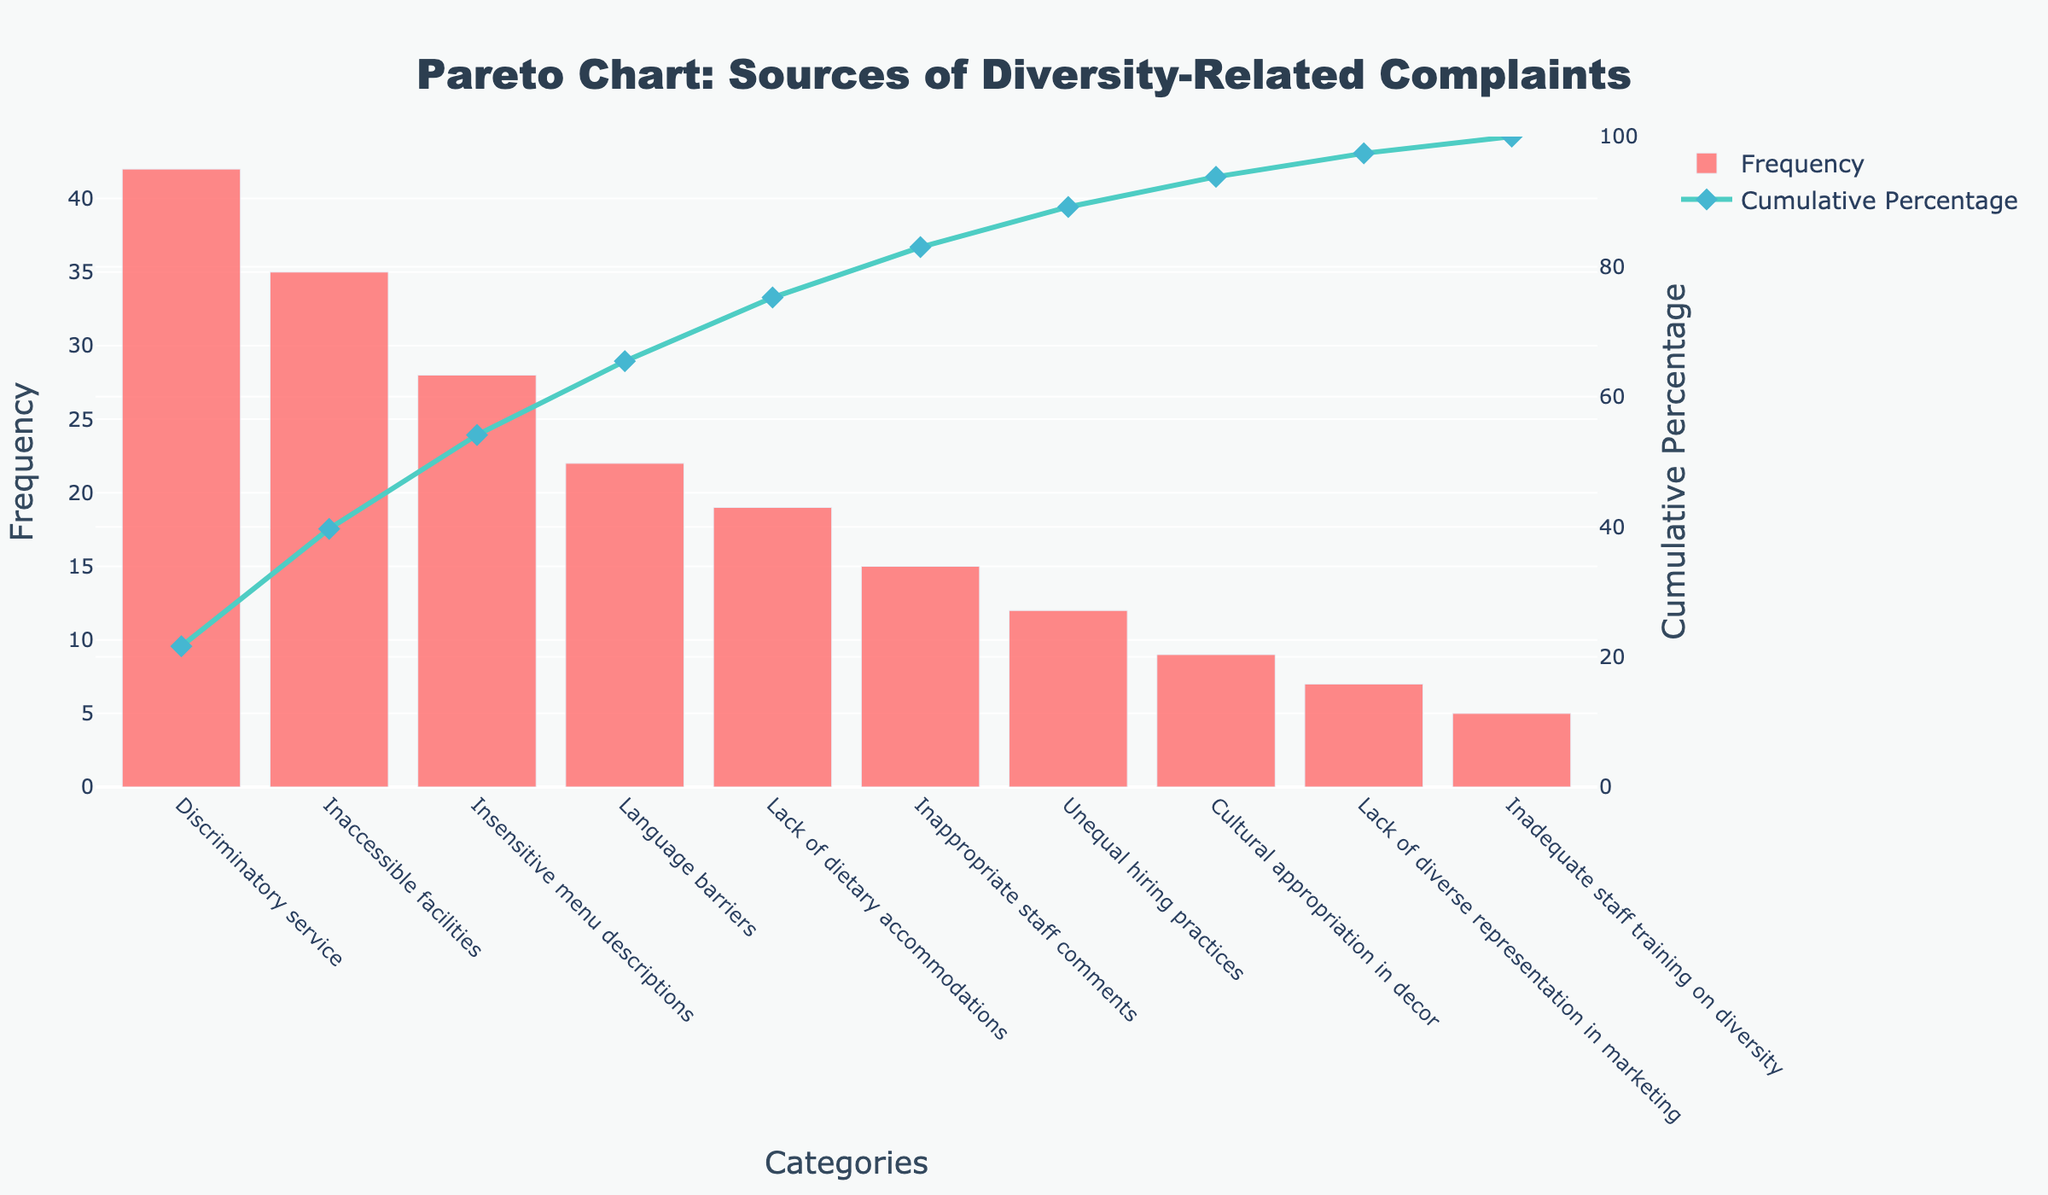What is the title of the chart? The title is prominently displayed at the top of the chart, centered and written in larger, bold font.
Answer: Pareto Chart: Sources of Diversity-Related Complaints How many categories of diversity-related complaints are listed in the chart? By counting the bars on the x-axis, we can see that there are 10 different categories.
Answer: 10 What is the category with the highest frequency of complaints? The highest bar in the chart represents the category with the highest frequency.
Answer: Discriminatory service What is the cumulative percentage of the top three categories combined? Add the cumulative percentages of "Discriminatory service," "Inaccessible facilities," and "Insensitive menu descriptions" displayed where the markers touch the line.
Answer: 66.91% Which category has the lowest frequency of complaints, and what is the frequency? The shortest bar represents the category with the lowest frequency, which we can find by looking at the y-axis value of that bar.
Answer: Inadequate staff training on diversity, 5 How does the frequency of "Language barriers" compare to "Lack of dietary accommodations"? By looking at the heights of their respective bars on the y-axis, we can see "Language barriers" is higher.
Answer: Language barriers is greater What percentage of total complaints does "Insensitive menu descriptions" represent? Divide the frequency of "Insensitive menu descriptions" (28) by the total number of complaints and multiply by 100 to get the percentage.
Answer: 15.64% Which category reaches a cumulative percentage of approximately 82%? Identify where the line for cumulative percentage crosses the 82% mark on the right y-axis and check the corresponding category below.
Answer: Unequal hiring practices What can you infer about the distribution of complaints among the different categories? The Pareto chart shows a few categories with high frequencies (to the left) and many categories with low frequencies (to the right), indicating that most complaints come from a small number of sources.
Answer: A few categories dominate in frequency Is the cumulative percentage line always increasing, and why? The cumulative percentage cannot decrease because it represents a running total; each additional category adds to the previous total.
Answer: Yes, it’s cumulative 